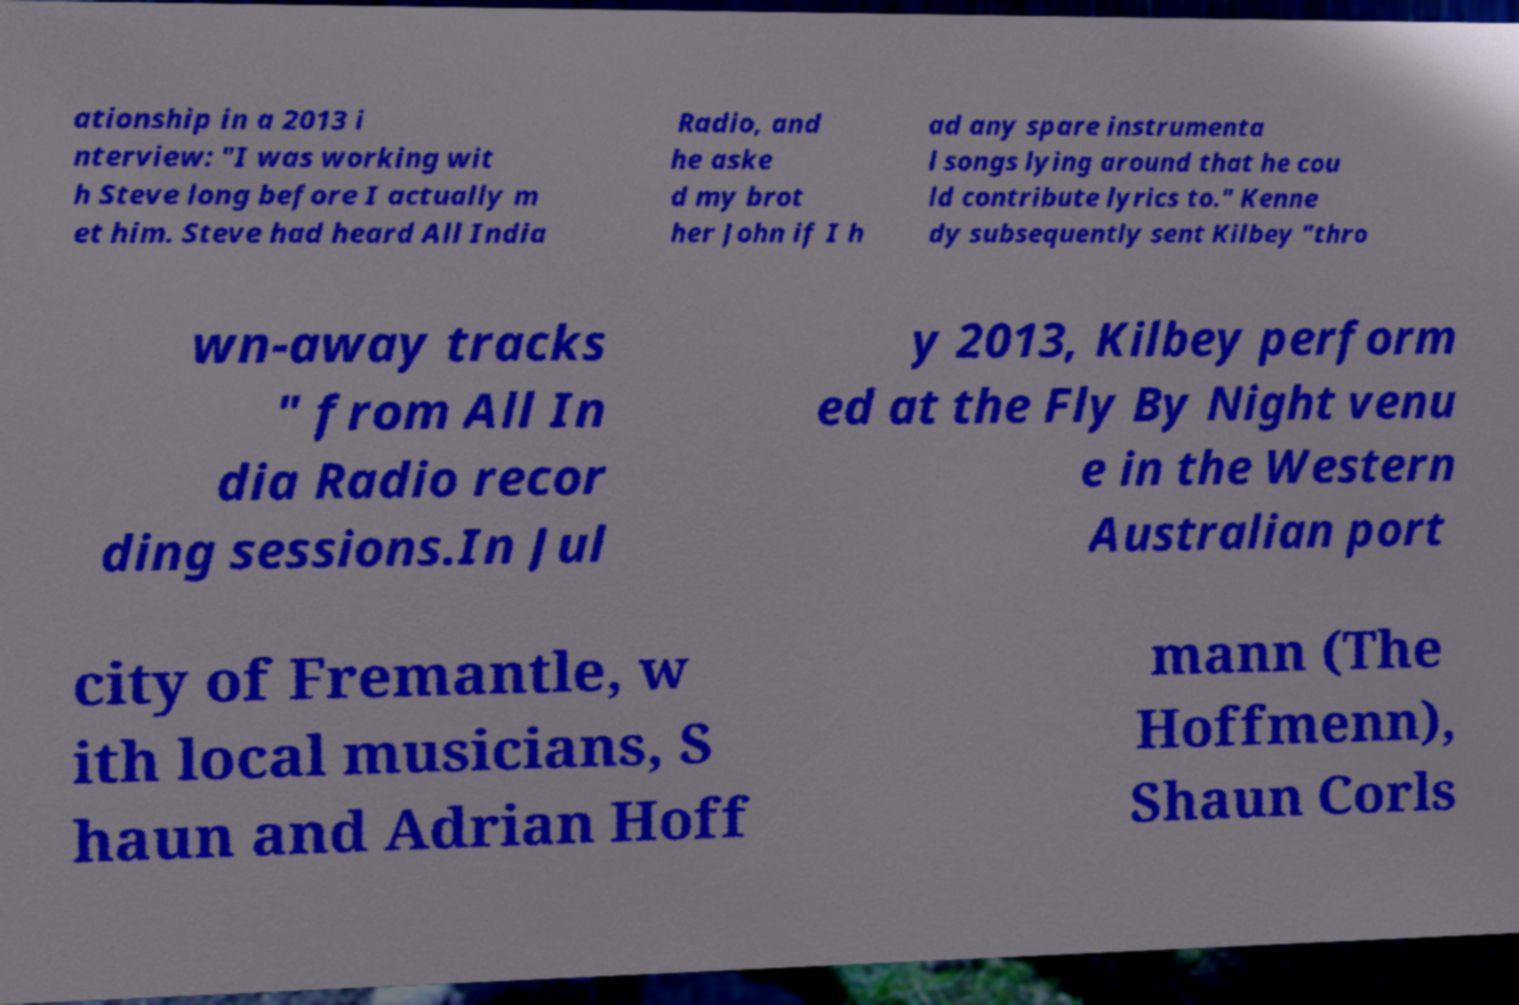Can you accurately transcribe the text from the provided image for me? ationship in a 2013 i nterview: "I was working wit h Steve long before I actually m et him. Steve had heard All India Radio, and he aske d my brot her John if I h ad any spare instrumenta l songs lying around that he cou ld contribute lyrics to." Kenne dy subsequently sent Kilbey "thro wn-away tracks " from All In dia Radio recor ding sessions.In Jul y 2013, Kilbey perform ed at the Fly By Night venu e in the Western Australian port city of Fremantle, w ith local musicians, S haun and Adrian Hoff mann (The Hoffmenn), Shaun Corls 